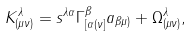Convert formula to latex. <formula><loc_0><loc_0><loc_500><loc_500>K ^ { \lambda } _ { ( \mu \nu ) } = s ^ { \lambda \alpha } \Gamma ^ { \beta } _ { [ \alpha ( \nu ] } a _ { \beta \mu ) } + \Omega ^ { \lambda } _ { ( \mu \nu ) } ,</formula> 